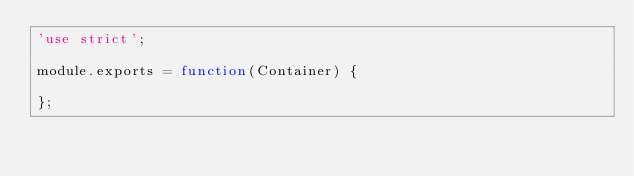Convert code to text. <code><loc_0><loc_0><loc_500><loc_500><_JavaScript_>'use strict';

module.exports = function(Container) {

};
</code> 